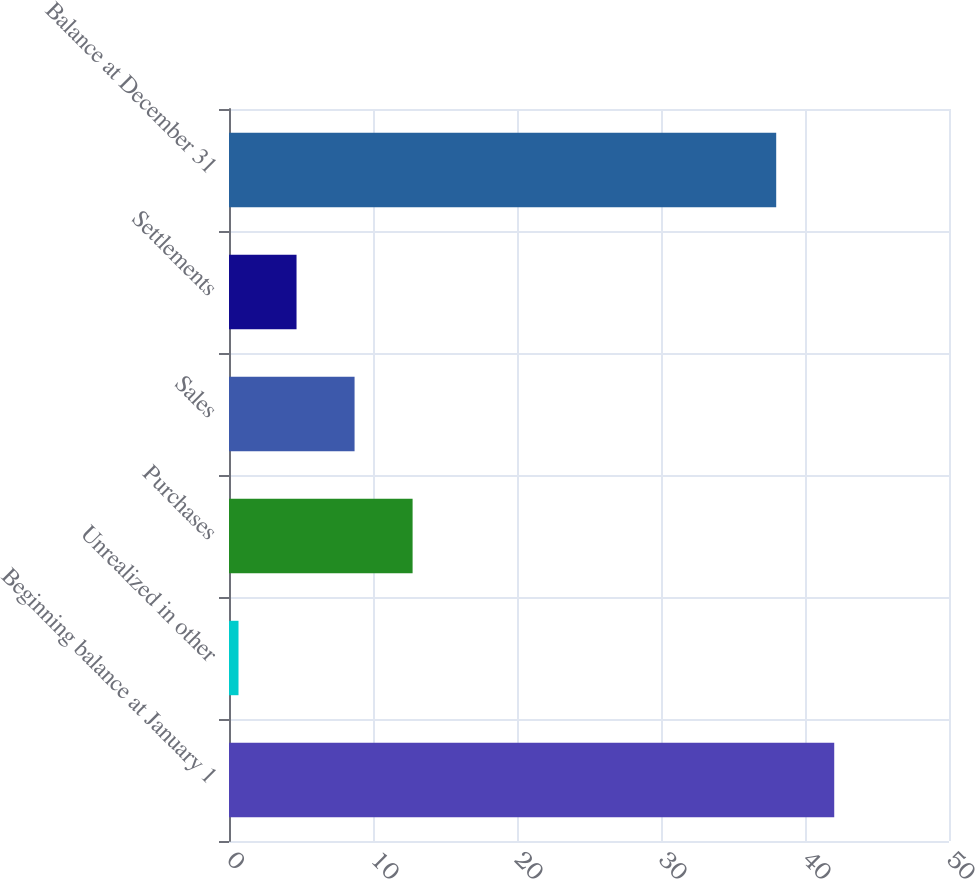Convert chart. <chart><loc_0><loc_0><loc_500><loc_500><bar_chart><fcel>Beginning balance at January 1<fcel>Unrealized in other<fcel>Purchases<fcel>Sales<fcel>Settlements<fcel>Balance at December 31<nl><fcel>42.03<fcel>0.66<fcel>12.75<fcel>8.72<fcel>4.69<fcel>38<nl></chart> 